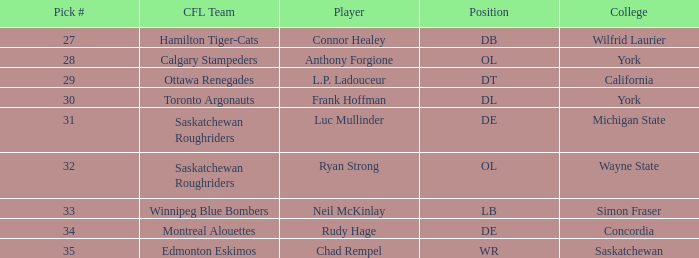What was the highest Pick # for the College of Simon Fraser? 33.0. 